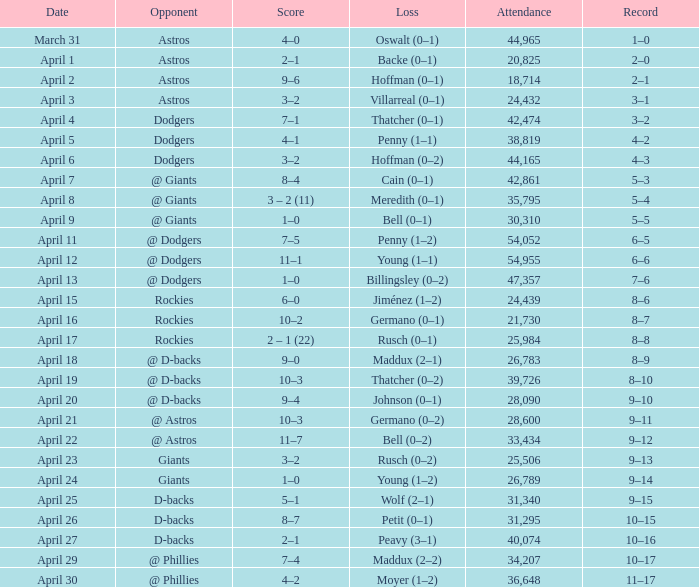What was the score on April 21? 10–3. 